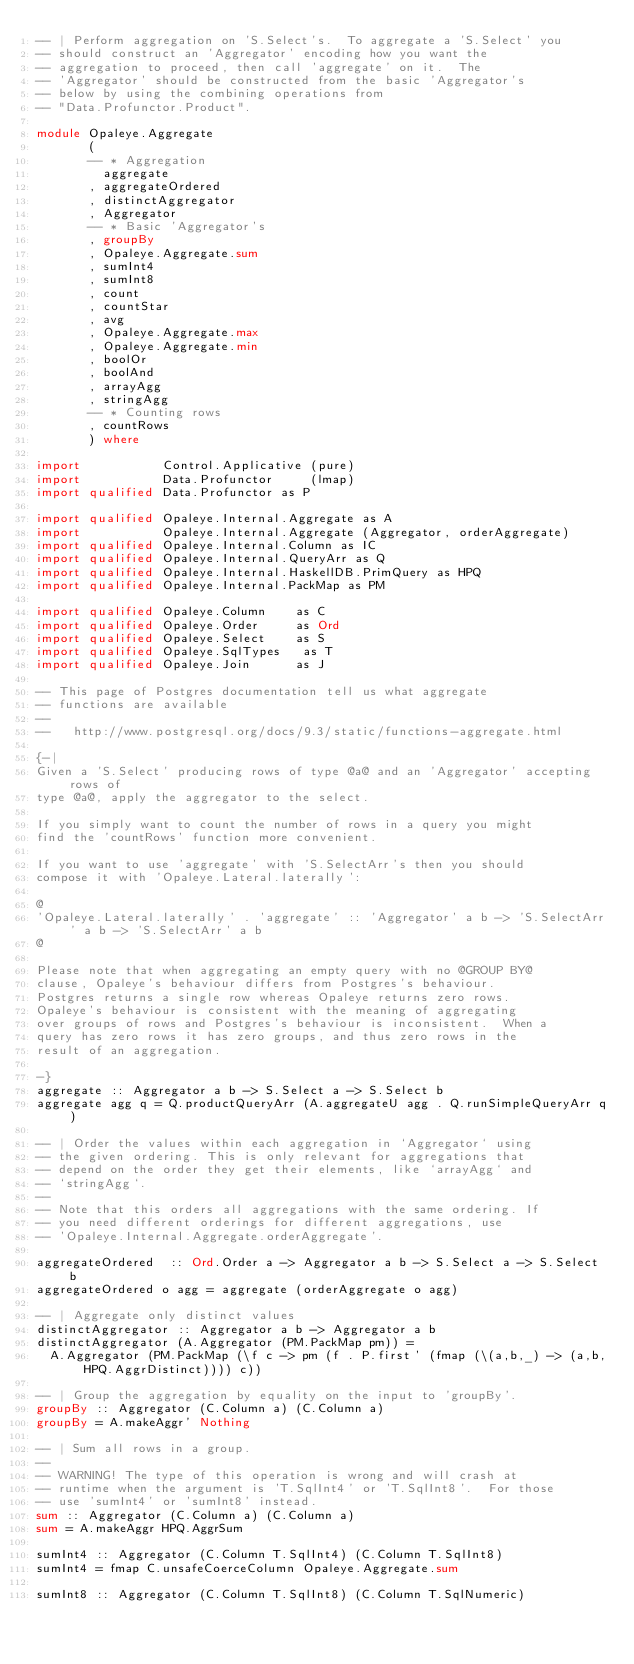Convert code to text. <code><loc_0><loc_0><loc_500><loc_500><_Haskell_>-- | Perform aggregation on 'S.Select's.  To aggregate a 'S.Select' you
-- should construct an 'Aggregator' encoding how you want the
-- aggregation to proceed, then call 'aggregate' on it.  The
-- 'Aggregator' should be constructed from the basic 'Aggregator's
-- below by using the combining operations from
-- "Data.Profunctor.Product".

module Opaleye.Aggregate
       (
       -- * Aggregation
         aggregate
       , aggregateOrdered
       , distinctAggregator
       , Aggregator
       -- * Basic 'Aggregator's
       , groupBy
       , Opaleye.Aggregate.sum
       , sumInt4
       , sumInt8
       , count
       , countStar
       , avg
       , Opaleye.Aggregate.max
       , Opaleye.Aggregate.min
       , boolOr
       , boolAnd
       , arrayAgg
       , stringAgg
       -- * Counting rows
       , countRows
       ) where

import           Control.Applicative (pure)
import           Data.Profunctor     (lmap)
import qualified Data.Profunctor as P

import qualified Opaleye.Internal.Aggregate as A
import           Opaleye.Internal.Aggregate (Aggregator, orderAggregate)
import qualified Opaleye.Internal.Column as IC
import qualified Opaleye.Internal.QueryArr as Q
import qualified Opaleye.Internal.HaskellDB.PrimQuery as HPQ
import qualified Opaleye.Internal.PackMap as PM

import qualified Opaleye.Column    as C
import qualified Opaleye.Order     as Ord
import qualified Opaleye.Select    as S
import qualified Opaleye.SqlTypes   as T
import qualified Opaleye.Join      as J

-- This page of Postgres documentation tell us what aggregate
-- functions are available
--
--   http://www.postgresql.org/docs/9.3/static/functions-aggregate.html

{-|
Given a 'S.Select' producing rows of type @a@ and an 'Aggregator' accepting rows of
type @a@, apply the aggregator to the select.

If you simply want to count the number of rows in a query you might
find the 'countRows' function more convenient.

If you want to use 'aggregate' with 'S.SelectArr's then you should
compose it with 'Opaleye.Lateral.laterally':

@
'Opaleye.Lateral.laterally' . 'aggregate' :: 'Aggregator' a b -> 'S.SelectArr' a b -> 'S.SelectArr' a b
@

Please note that when aggregating an empty query with no @GROUP BY@
clause, Opaleye's behaviour differs from Postgres's behaviour.
Postgres returns a single row whereas Opaleye returns zero rows.
Opaleye's behaviour is consistent with the meaning of aggregating
over groups of rows and Postgres's behaviour is inconsistent.  When a
query has zero rows it has zero groups, and thus zero rows in the
result of an aggregation.

-}
aggregate :: Aggregator a b -> S.Select a -> S.Select b
aggregate agg q = Q.productQueryArr (A.aggregateU agg . Q.runSimpleQueryArr q)

-- | Order the values within each aggregation in `Aggregator` using
-- the given ordering. This is only relevant for aggregations that
-- depend on the order they get their elements, like `arrayAgg` and
-- `stringAgg`.
--
-- Note that this orders all aggregations with the same ordering. If
-- you need different orderings for different aggregations, use
-- 'Opaleye.Internal.Aggregate.orderAggregate'.

aggregateOrdered  :: Ord.Order a -> Aggregator a b -> S.Select a -> S.Select b
aggregateOrdered o agg = aggregate (orderAggregate o agg)

-- | Aggregate only distinct values
distinctAggregator :: Aggregator a b -> Aggregator a b
distinctAggregator (A.Aggregator (PM.PackMap pm)) =
  A.Aggregator (PM.PackMap (\f c -> pm (f . P.first' (fmap (\(a,b,_) -> (a,b,HPQ.AggrDistinct)))) c))

-- | Group the aggregation by equality on the input to 'groupBy'.
groupBy :: Aggregator (C.Column a) (C.Column a)
groupBy = A.makeAggr' Nothing

-- | Sum all rows in a group.
--
-- WARNING! The type of this operation is wrong and will crash at
-- runtime when the argument is 'T.SqlInt4' or 'T.SqlInt8'.  For those
-- use 'sumInt4' or 'sumInt8' instead.
sum :: Aggregator (C.Column a) (C.Column a)
sum = A.makeAggr HPQ.AggrSum

sumInt4 :: Aggregator (C.Column T.SqlInt4) (C.Column T.SqlInt8)
sumInt4 = fmap C.unsafeCoerceColumn Opaleye.Aggregate.sum

sumInt8 :: Aggregator (C.Column T.SqlInt8) (C.Column T.SqlNumeric)</code> 